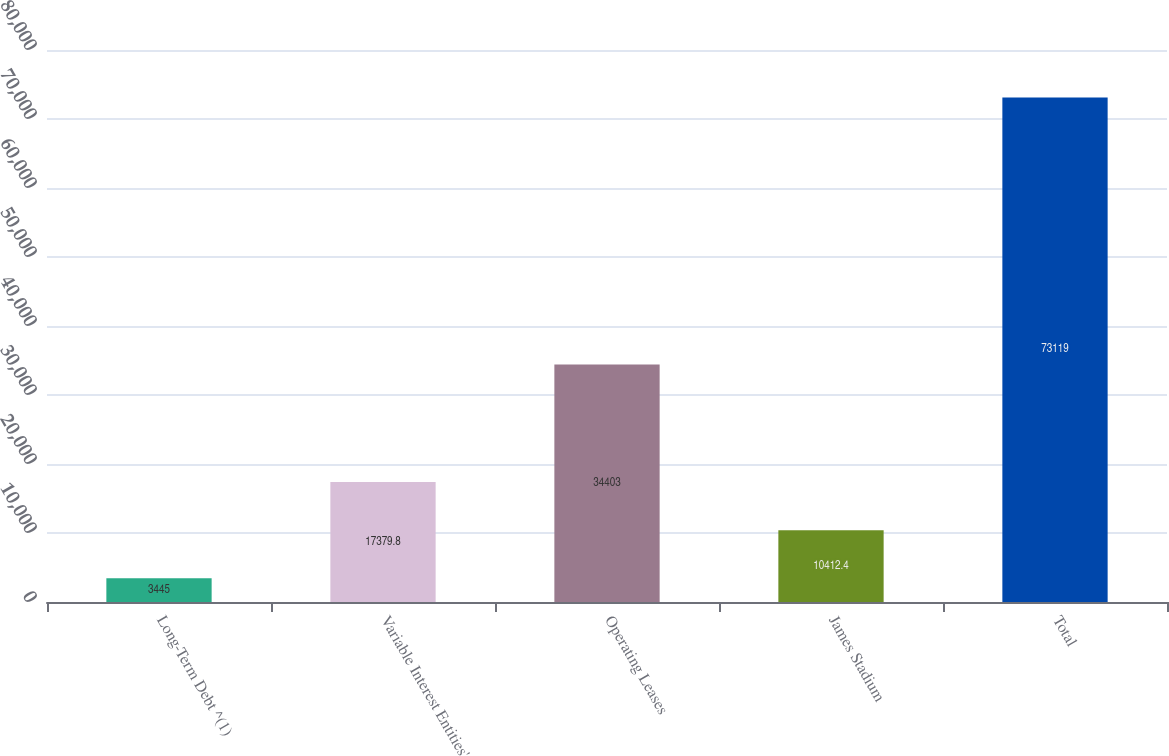<chart> <loc_0><loc_0><loc_500><loc_500><bar_chart><fcel>Long-Term Debt ^(1)<fcel>Variable Interest Entities'<fcel>Operating Leases<fcel>James Stadium<fcel>Total<nl><fcel>3445<fcel>17379.8<fcel>34403<fcel>10412.4<fcel>73119<nl></chart> 